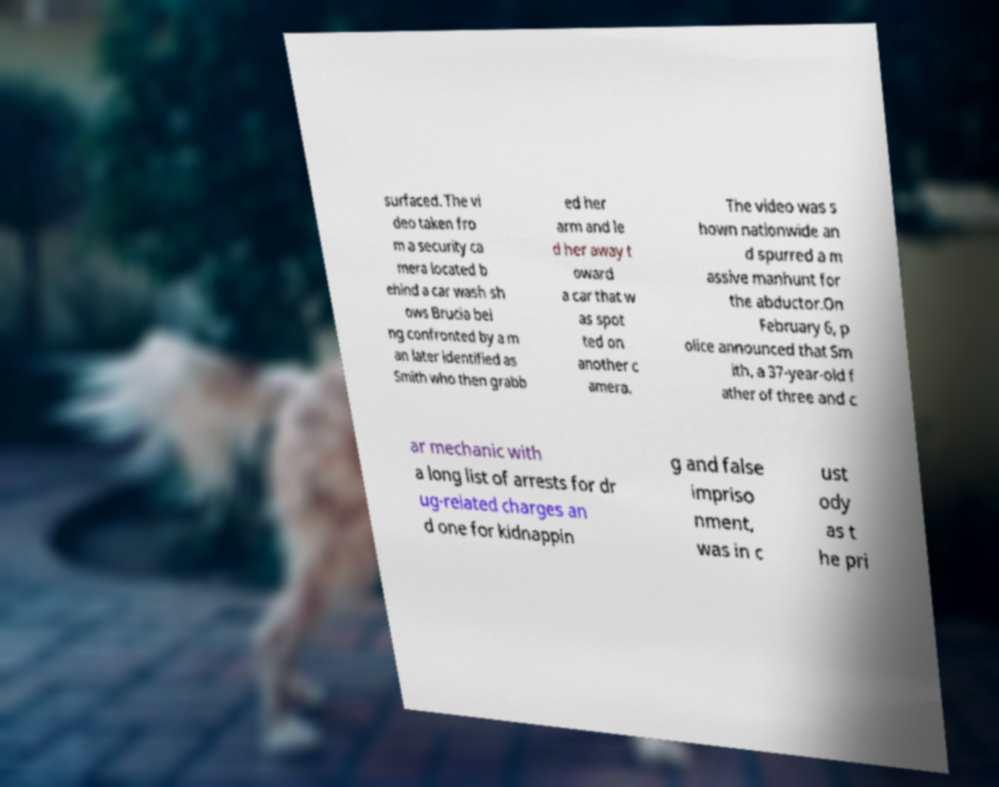I need the written content from this picture converted into text. Can you do that? surfaced. The vi deo taken fro m a security ca mera located b ehind a car wash sh ows Brucia bei ng confronted by a m an later identified as Smith who then grabb ed her arm and le d her away t oward a car that w as spot ted on another c amera. The video was s hown nationwide an d spurred a m assive manhunt for the abductor.On February 6, p olice announced that Sm ith, a 37-year-old f ather of three and c ar mechanic with a long list of arrests for dr ug-related charges an d one for kidnappin g and false impriso nment, was in c ust ody as t he pri 